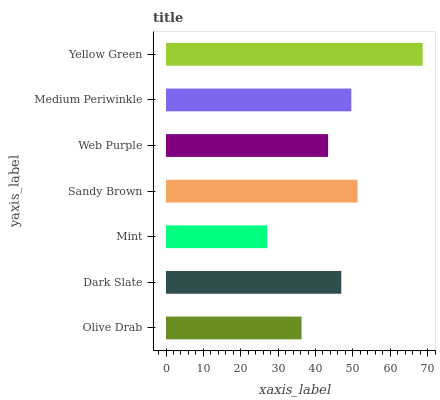Is Mint the minimum?
Answer yes or no. Yes. Is Yellow Green the maximum?
Answer yes or no. Yes. Is Dark Slate the minimum?
Answer yes or no. No. Is Dark Slate the maximum?
Answer yes or no. No. Is Dark Slate greater than Olive Drab?
Answer yes or no. Yes. Is Olive Drab less than Dark Slate?
Answer yes or no. Yes. Is Olive Drab greater than Dark Slate?
Answer yes or no. No. Is Dark Slate less than Olive Drab?
Answer yes or no. No. Is Dark Slate the high median?
Answer yes or no. Yes. Is Dark Slate the low median?
Answer yes or no. Yes. Is Olive Drab the high median?
Answer yes or no. No. Is Mint the low median?
Answer yes or no. No. 